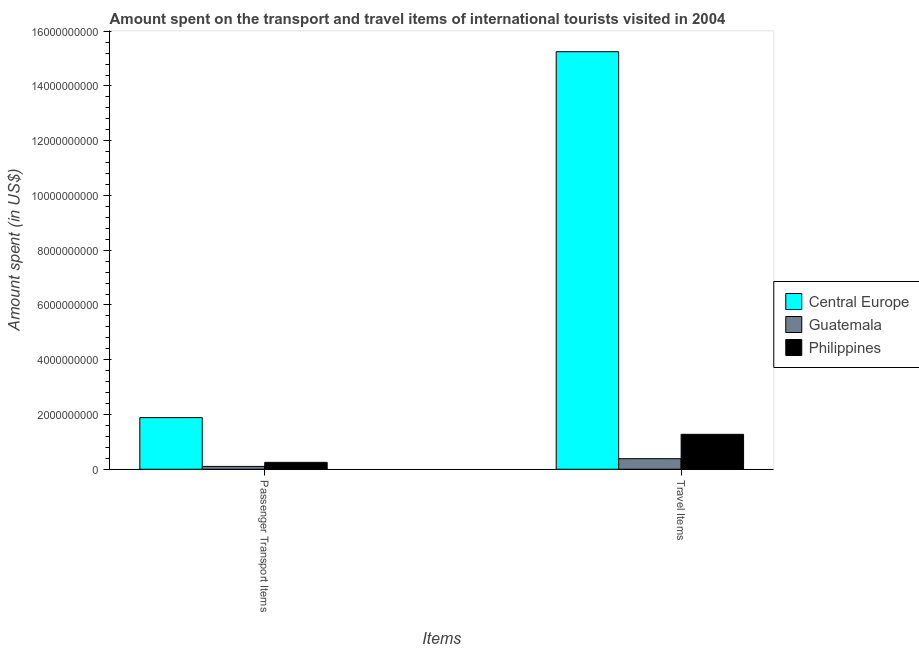Are the number of bars on each tick of the X-axis equal?
Ensure brevity in your answer.  Yes. How many bars are there on the 2nd tick from the right?
Keep it short and to the point. 3. What is the label of the 2nd group of bars from the left?
Your answer should be very brief. Travel Items. What is the amount spent in travel items in Guatemala?
Offer a very short reply. 3.85e+08. Across all countries, what is the maximum amount spent in travel items?
Offer a very short reply. 1.53e+1. Across all countries, what is the minimum amount spent on passenger transport items?
Your response must be concise. 1.03e+08. In which country was the amount spent on passenger transport items maximum?
Provide a succinct answer. Central Europe. In which country was the amount spent in travel items minimum?
Give a very brief answer. Guatemala. What is the total amount spent on passenger transport items in the graph?
Offer a terse response. 2.24e+09. What is the difference between the amount spent on passenger transport items in Philippines and that in Central Europe?
Make the answer very short. -1.64e+09. What is the difference between the amount spent on passenger transport items in Philippines and the amount spent in travel items in Guatemala?
Offer a very short reply. -1.34e+08. What is the average amount spent in travel items per country?
Offer a terse response. 5.64e+09. What is the difference between the amount spent in travel items and amount spent on passenger transport items in Philippines?
Provide a succinct answer. 1.02e+09. In how many countries, is the amount spent on passenger transport items greater than 4800000000 US$?
Keep it short and to the point. 0. What is the ratio of the amount spent in travel items in Philippines to that in Central Europe?
Provide a succinct answer. 0.08. Is the amount spent in travel items in Philippines less than that in Guatemala?
Offer a terse response. No. In how many countries, is the amount spent on passenger transport items greater than the average amount spent on passenger transport items taken over all countries?
Your response must be concise. 1. What does the 2nd bar from the left in Passenger Transport Items represents?
Your response must be concise. Guatemala. Are all the bars in the graph horizontal?
Offer a very short reply. No. What is the difference between two consecutive major ticks on the Y-axis?
Provide a succinct answer. 2.00e+09. Does the graph contain grids?
Your response must be concise. No. Where does the legend appear in the graph?
Provide a short and direct response. Center right. How are the legend labels stacked?
Offer a terse response. Vertical. What is the title of the graph?
Your response must be concise. Amount spent on the transport and travel items of international tourists visited in 2004. Does "Greece" appear as one of the legend labels in the graph?
Your answer should be compact. No. What is the label or title of the X-axis?
Offer a terse response. Items. What is the label or title of the Y-axis?
Make the answer very short. Amount spent (in US$). What is the Amount spent (in US$) in Central Europe in Passenger Transport Items?
Your response must be concise. 1.89e+09. What is the Amount spent (in US$) of Guatemala in Passenger Transport Items?
Your answer should be very brief. 1.03e+08. What is the Amount spent (in US$) in Philippines in Passenger Transport Items?
Offer a terse response. 2.51e+08. What is the Amount spent (in US$) in Central Europe in Travel Items?
Give a very brief answer. 1.53e+1. What is the Amount spent (in US$) of Guatemala in Travel Items?
Keep it short and to the point. 3.85e+08. What is the Amount spent (in US$) in Philippines in Travel Items?
Provide a short and direct response. 1.28e+09. Across all Items, what is the maximum Amount spent (in US$) in Central Europe?
Provide a succinct answer. 1.53e+1. Across all Items, what is the maximum Amount spent (in US$) in Guatemala?
Your response must be concise. 3.85e+08. Across all Items, what is the maximum Amount spent (in US$) in Philippines?
Give a very brief answer. 1.28e+09. Across all Items, what is the minimum Amount spent (in US$) in Central Europe?
Your answer should be compact. 1.89e+09. Across all Items, what is the minimum Amount spent (in US$) of Guatemala?
Your answer should be compact. 1.03e+08. Across all Items, what is the minimum Amount spent (in US$) in Philippines?
Your response must be concise. 2.51e+08. What is the total Amount spent (in US$) in Central Europe in the graph?
Offer a terse response. 1.71e+1. What is the total Amount spent (in US$) in Guatemala in the graph?
Give a very brief answer. 4.88e+08. What is the total Amount spent (in US$) in Philippines in the graph?
Provide a succinct answer. 1.53e+09. What is the difference between the Amount spent (in US$) of Central Europe in Passenger Transport Items and that in Travel Items?
Make the answer very short. -1.34e+1. What is the difference between the Amount spent (in US$) of Guatemala in Passenger Transport Items and that in Travel Items?
Provide a short and direct response. -2.82e+08. What is the difference between the Amount spent (in US$) of Philippines in Passenger Transport Items and that in Travel Items?
Keep it short and to the point. -1.02e+09. What is the difference between the Amount spent (in US$) in Central Europe in Passenger Transport Items and the Amount spent (in US$) in Guatemala in Travel Items?
Your answer should be very brief. 1.50e+09. What is the difference between the Amount spent (in US$) in Central Europe in Passenger Transport Items and the Amount spent (in US$) in Philippines in Travel Items?
Your answer should be very brief. 6.11e+08. What is the difference between the Amount spent (in US$) in Guatemala in Passenger Transport Items and the Amount spent (in US$) in Philippines in Travel Items?
Keep it short and to the point. -1.17e+09. What is the average Amount spent (in US$) in Central Europe per Items?
Ensure brevity in your answer.  8.57e+09. What is the average Amount spent (in US$) of Guatemala per Items?
Provide a succinct answer. 2.44e+08. What is the average Amount spent (in US$) of Philippines per Items?
Ensure brevity in your answer.  7.63e+08. What is the difference between the Amount spent (in US$) in Central Europe and Amount spent (in US$) in Guatemala in Passenger Transport Items?
Your answer should be very brief. 1.78e+09. What is the difference between the Amount spent (in US$) in Central Europe and Amount spent (in US$) in Philippines in Passenger Transport Items?
Provide a short and direct response. 1.64e+09. What is the difference between the Amount spent (in US$) of Guatemala and Amount spent (in US$) of Philippines in Passenger Transport Items?
Give a very brief answer. -1.48e+08. What is the difference between the Amount spent (in US$) in Central Europe and Amount spent (in US$) in Guatemala in Travel Items?
Keep it short and to the point. 1.49e+1. What is the difference between the Amount spent (in US$) in Central Europe and Amount spent (in US$) in Philippines in Travel Items?
Give a very brief answer. 1.40e+1. What is the difference between the Amount spent (in US$) of Guatemala and Amount spent (in US$) of Philippines in Travel Items?
Ensure brevity in your answer.  -8.90e+08. What is the ratio of the Amount spent (in US$) in Central Europe in Passenger Transport Items to that in Travel Items?
Keep it short and to the point. 0.12. What is the ratio of the Amount spent (in US$) in Guatemala in Passenger Transport Items to that in Travel Items?
Offer a very short reply. 0.27. What is the ratio of the Amount spent (in US$) in Philippines in Passenger Transport Items to that in Travel Items?
Your answer should be compact. 0.2. What is the difference between the highest and the second highest Amount spent (in US$) of Central Europe?
Make the answer very short. 1.34e+1. What is the difference between the highest and the second highest Amount spent (in US$) of Guatemala?
Make the answer very short. 2.82e+08. What is the difference between the highest and the second highest Amount spent (in US$) in Philippines?
Provide a short and direct response. 1.02e+09. What is the difference between the highest and the lowest Amount spent (in US$) of Central Europe?
Offer a very short reply. 1.34e+1. What is the difference between the highest and the lowest Amount spent (in US$) in Guatemala?
Your answer should be very brief. 2.82e+08. What is the difference between the highest and the lowest Amount spent (in US$) of Philippines?
Provide a succinct answer. 1.02e+09. 